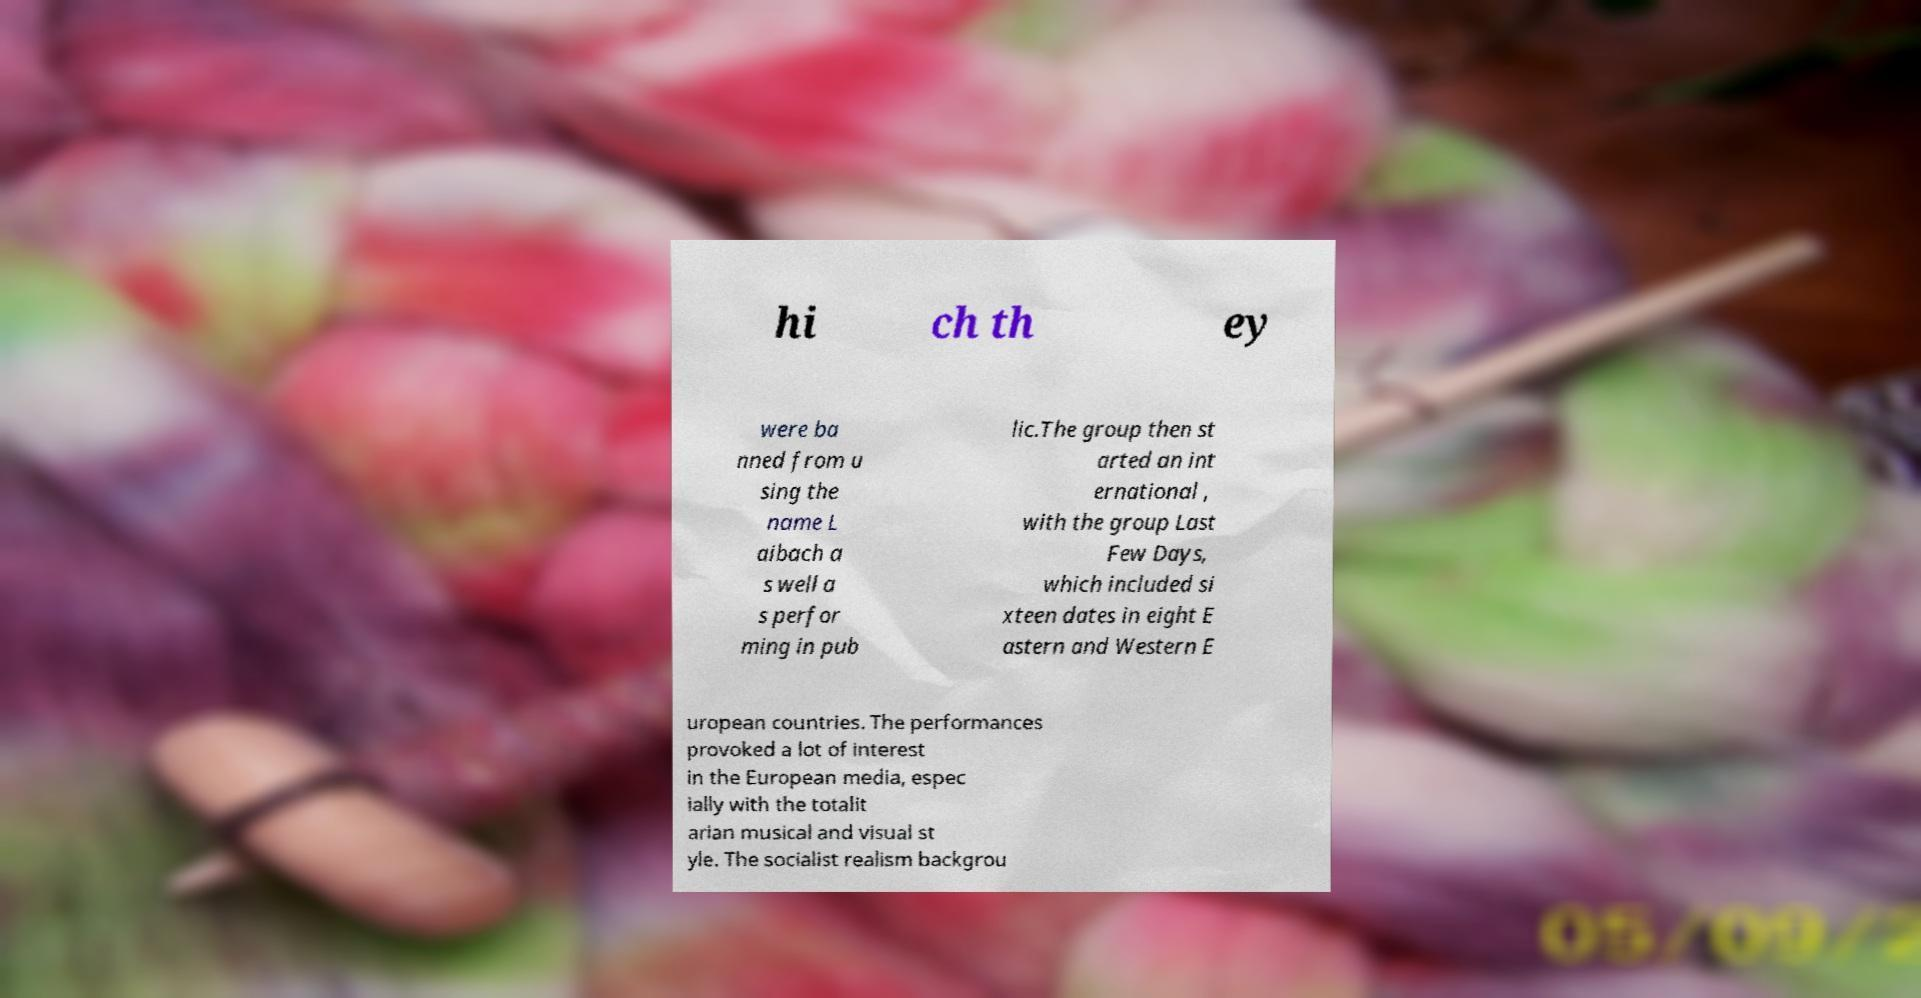I need the written content from this picture converted into text. Can you do that? hi ch th ey were ba nned from u sing the name L aibach a s well a s perfor ming in pub lic.The group then st arted an int ernational , with the group Last Few Days, which included si xteen dates in eight E astern and Western E uropean countries. The performances provoked a lot of interest in the European media, espec ially with the totalit arian musical and visual st yle. The socialist realism backgrou 